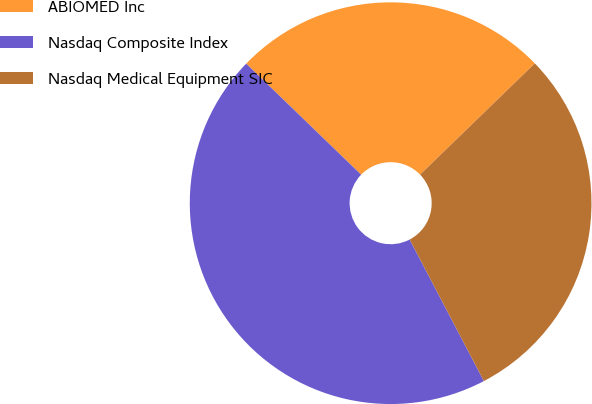Convert chart. <chart><loc_0><loc_0><loc_500><loc_500><pie_chart><fcel>ABIOMED Inc<fcel>Nasdaq Composite Index<fcel>Nasdaq Medical Equipment SIC<nl><fcel>25.52%<fcel>44.91%<fcel>29.57%<nl></chart> 